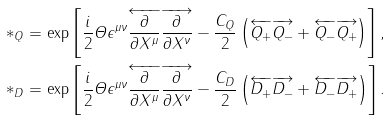Convert formula to latex. <formula><loc_0><loc_0><loc_500><loc_500>\ast _ { Q } & = \exp \left [ \frac { i } { 2 } \varTheta \epsilon ^ { \mu \nu } \overleftarrow { \frac { \partial } { \partial X ^ { \mu } } } \overrightarrow { \frac { \partial } { \partial X ^ { \nu } } } - \frac { C _ { Q } } { 2 } \left ( \overleftarrow { Q _ { + } } \overrightarrow { Q _ { - } } + \overleftarrow { Q _ { - } } \overrightarrow { Q _ { + } } \right ) \right ] , \\ \ast _ { D } & = \exp \left [ \frac { i } { 2 } \varTheta \epsilon ^ { \mu \nu } \overleftarrow { \frac { \partial } { \partial X ^ { \mu } } } \overrightarrow { \frac { \partial } { \partial X ^ { \nu } } } - \frac { C _ { D } } { 2 } \left ( \overleftarrow { D _ { + } } \overrightarrow { D _ { - } } + \overleftarrow { D _ { - } } \overrightarrow { D _ { + } } \right ) \right ] .</formula> 